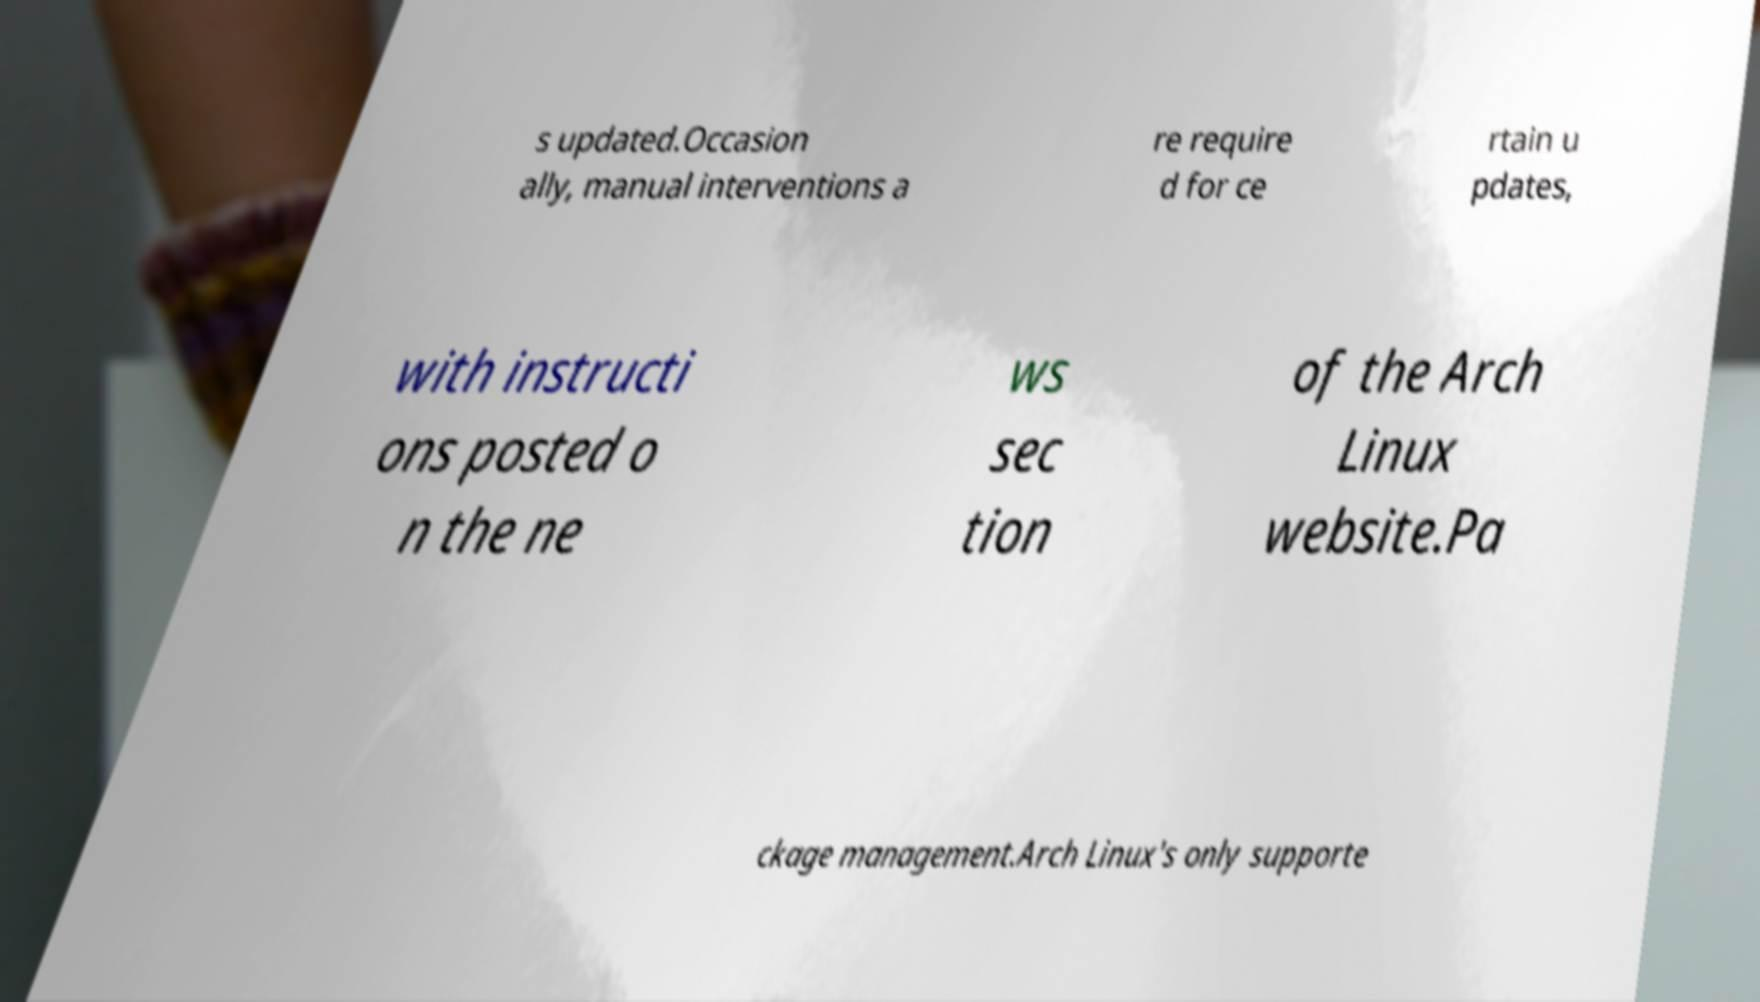There's text embedded in this image that I need extracted. Can you transcribe it verbatim? s updated.Occasion ally, manual interventions a re require d for ce rtain u pdates, with instructi ons posted o n the ne ws sec tion of the Arch Linux website.Pa ckage management.Arch Linux's only supporte 